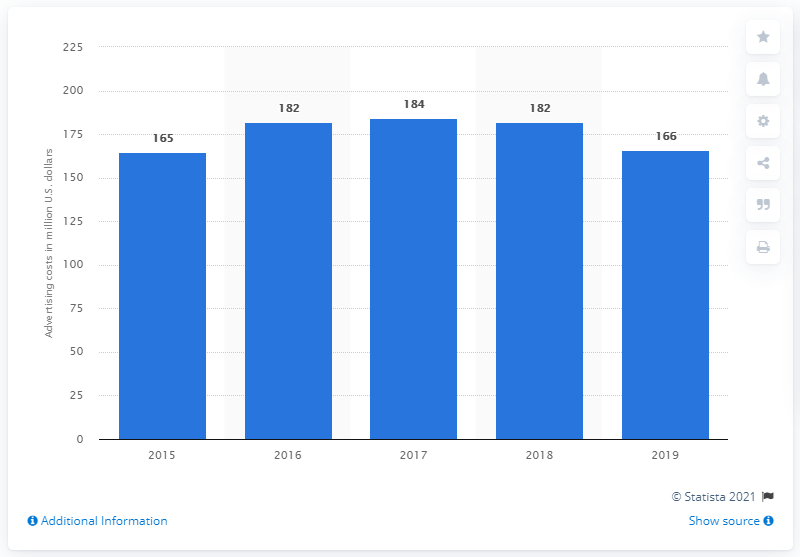Point out several critical features in this image. In 2019, Foot Locker spent approximately $166 million on advertising. In 2015, Foot Locker spent approximately $166 on advertising. 